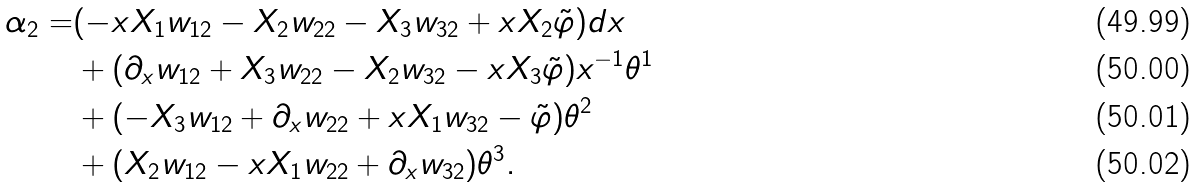Convert formula to latex. <formula><loc_0><loc_0><loc_500><loc_500>\alpha _ { 2 } = & ( - x X _ { 1 } w _ { 1 2 } - X _ { 2 } w _ { 2 2 } - X _ { 3 } w _ { 3 2 } + x X _ { 2 } \tilde { \varphi } ) d x \\ & + ( \partial _ { x } w _ { 1 2 } + X _ { 3 } w _ { 2 2 } - X _ { 2 } w _ { 3 2 } - x X _ { 3 } \tilde { \varphi } ) x ^ { - 1 } \theta ^ { 1 } \\ & + ( - X _ { 3 } w _ { 1 2 } + \partial _ { x } w _ { 2 2 } + x X _ { 1 } w _ { 3 2 } - \tilde { \varphi } ) \theta ^ { 2 } \\ & + ( X _ { 2 } w _ { 1 2 } - x X _ { 1 } w _ { 2 2 } + \partial _ { x } w _ { 3 2 } ) \theta ^ { 3 } .</formula> 